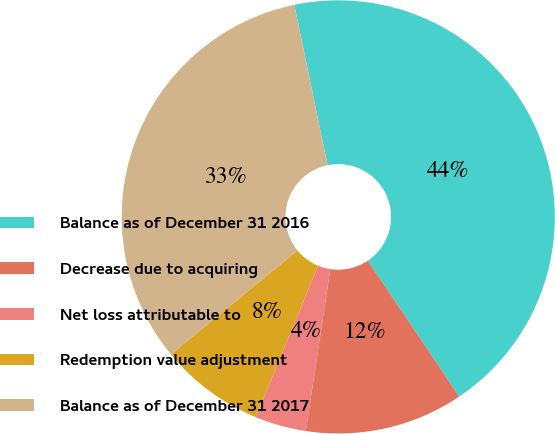<chart> <loc_0><loc_0><loc_500><loc_500><pie_chart><fcel>Balance as of December 31 2016<fcel>Decrease due to acquiring<fcel>Net loss attributable to<fcel>Redemption value adjustment<fcel>Balance as of December 31 2017<nl><fcel>43.83%<fcel>11.83%<fcel>3.83%<fcel>7.83%<fcel>32.7%<nl></chart> 